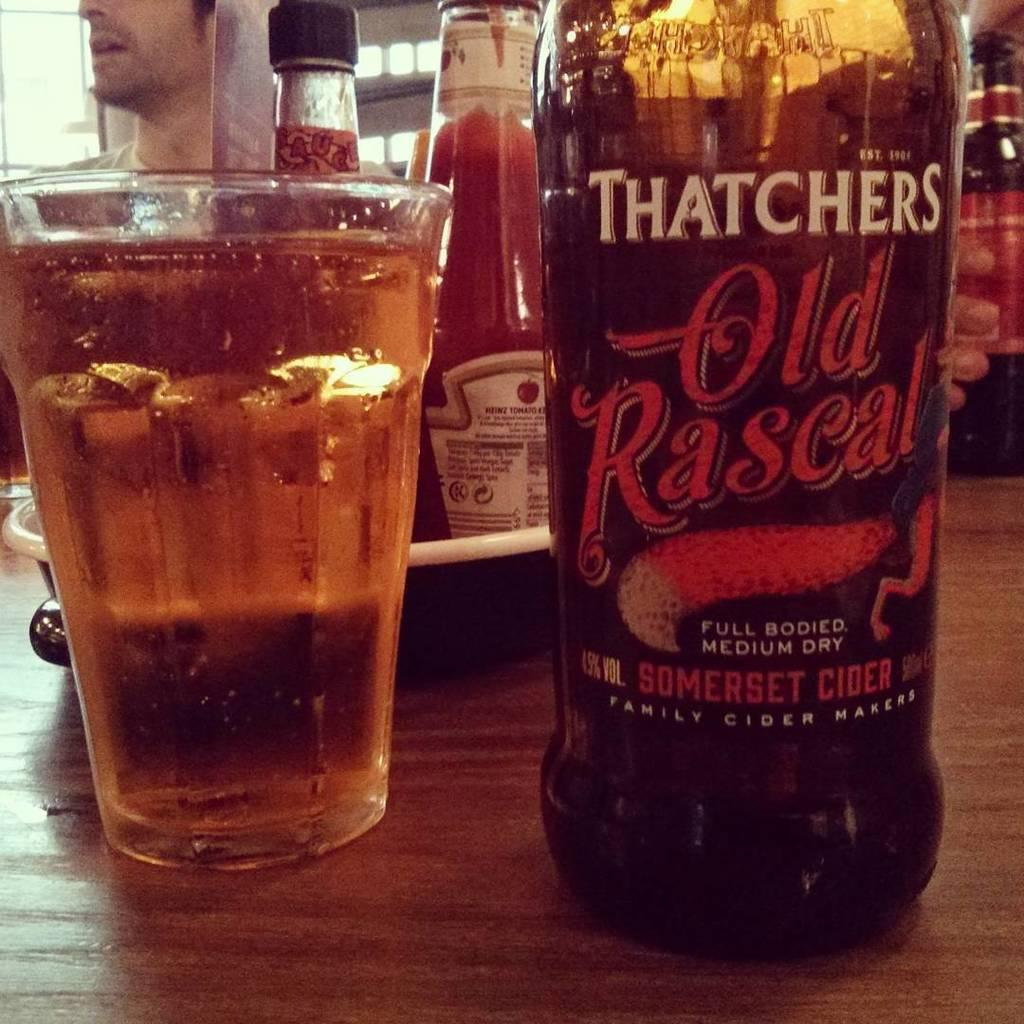Provide a one-sentence caption for the provided image. A bottle of Thatchers Somerset Cider sits on a table next to a full glass. 